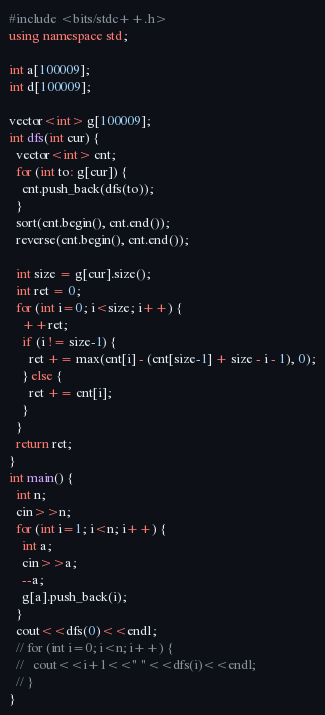<code> <loc_0><loc_0><loc_500><loc_500><_C++_>#include <bits/stdc++.h>
using namespace std;

int a[100009];
int d[100009];

vector<int> g[100009];
int dfs(int cur) {
  vector<int> cnt;
  for (int to: g[cur]) {
    cnt.push_back(dfs(to));
  }
  sort(cnt.begin(), cnt.end());
  reverse(cnt.begin(), cnt.end());

  int size = g[cur].size();
  int ret = 0;
  for (int i=0; i<size; i++) {
    ++ret;
    if (i != size-1) {
      ret += max(cnt[i] - (cnt[size-1] + size - i - 1), 0);
    } else {
      ret += cnt[i];
    }
  }
  return ret;
}
int main() {
  int n;
  cin>>n;
  for (int i=1; i<n; i++) {
    int a;
    cin>>a;
    --a;
    g[a].push_back(i);
  }
  cout<<dfs(0)<<endl;
  // for (int i=0; i<n; i++) {
  //   cout<<i+1<<" "<<dfs(i)<<endl;
  // }
}</code> 